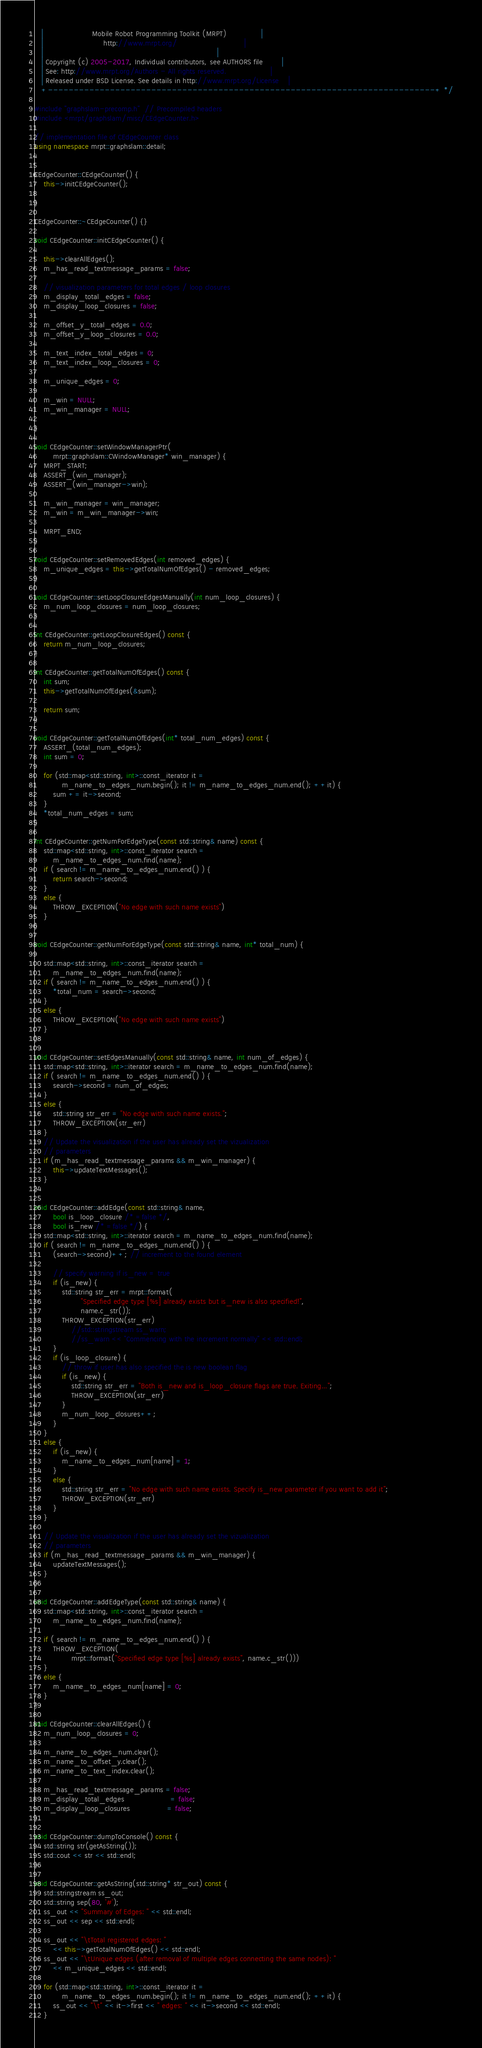Convert code to text. <code><loc_0><loc_0><loc_500><loc_500><_C++_>   |                     Mobile Robot Programming Toolkit (MRPT)               |
   |                          http://www.mrpt.org/                             |
   |                                                                           |
   | Copyright (c) 2005-2017, Individual contributors, see AUTHORS file        |
   | See: http://www.mrpt.org/Authors - All rights reserved.                   |
   | Released under BSD License. See details in http://www.mrpt.org/License    |
   +---------------------------------------------------------------------------+ */

#include "graphslam-precomp.h"  // Precompiled headers
#include <mrpt/graphslam/misc/CEdgeCounter.h>

// implementation file of CEdgeCounter class
using namespace mrpt::graphslam::detail;


CEdgeCounter::CEdgeCounter() {
	this->initCEdgeCounter();

}

CEdgeCounter::~CEdgeCounter() {}

void CEdgeCounter::initCEdgeCounter() {

	this->clearAllEdges();
	m_has_read_textmessage_params = false;

	// visualization parameters for total edges / loop closures
	m_display_total_edges = false;
	m_display_loop_closures = false;

	m_offset_y_total_edges = 0.0;
	m_offset_y_loop_closures = 0.0;

	m_text_index_total_edges = 0;
	m_text_index_loop_closures = 0;

	m_unique_edges = 0;

	m_win = NULL;
	m_win_manager = NULL;

}

void CEdgeCounter::setWindowManagerPtr(
		mrpt::graphslam::CWindowManager* win_manager) {
	MRPT_START;
	ASSERT_(win_manager);
	ASSERT_(win_manager->win);

	m_win_manager = win_manager;
	m_win = m_win_manager->win;

	MRPT_END;
}

void CEdgeCounter::setRemovedEdges(int removed_edges) {
	m_unique_edges = this->getTotalNumOfEdges() - removed_edges;
}

void CEdgeCounter::setLoopClosureEdgesManually(int num_loop_closures) {
	m_num_loop_closures = num_loop_closures;
}

int CEdgeCounter::getLoopClosureEdges() const {
	return m_num_loop_closures;
}

int CEdgeCounter::getTotalNumOfEdges() const {
	int sum;
	this->getTotalNumOfEdges(&sum);

	return sum;
}

void CEdgeCounter::getTotalNumOfEdges(int* total_num_edges) const {
	ASSERT_(total_num_edges);
	int sum = 0;

	for (std::map<std::string, int>::const_iterator it =
			m_name_to_edges_num.begin(); it != m_name_to_edges_num.end(); ++it) {
		sum += it->second;
	}
	*total_num_edges = sum;
}

int CEdgeCounter::getNumForEdgeType(const std::string& name) const {
	std::map<std::string, int>::const_iterator search =
		m_name_to_edges_num.find(name);
	if ( search != m_name_to_edges_num.end() ) {
		return search->second;
	}
	else {
		THROW_EXCEPTION("No edge with such name exists")
	}
}

void CEdgeCounter::getNumForEdgeType(const std::string& name, int* total_num) {

	std::map<std::string, int>::const_iterator search =
		m_name_to_edges_num.find(name);
	if ( search != m_name_to_edges_num.end() ) {
		*total_num = search->second;
	}
	else {
		THROW_EXCEPTION("No edge with such name exists")
	}
}

void CEdgeCounter::setEdgesManually(const std::string& name, int num_of_edges) {
	std::map<std::string, int>::iterator search = m_name_to_edges_num.find(name);
	if ( search != m_name_to_edges_num.end() ) {
		search->second = num_of_edges;
	}
	else {
		std::string str_err = "No edge with such name exists.";
		THROW_EXCEPTION(str_err)
	}
	// Update the visualization if the user has already set the vizualization
	// parameters
	if (m_has_read_textmessage_params && m_win_manager) {
		this->updateTextMessages();
	}
}

void CEdgeCounter::addEdge(const std::string& name,
		bool is_loop_closure /* =false */,
		bool is_new /* =false */) {
	std::map<std::string, int>::iterator search = m_name_to_edges_num.find(name);
	if ( search != m_name_to_edges_num.end() ) {
		(search->second)++; // increment to the found element

		// specify warning if is_new = true
		if (is_new) {
			std::string str_err = mrpt::format(
					"Specified edge type [%s] already exists but is_new is also specified!",
					name.c_str());
			THROW_EXCEPTION(str_err)
				//std::stringstream ss_warn;
				//ss_warn << "Commencing with the increment normally" << std::endl;
		}
		if (is_loop_closure) {
			// throw if user has also specified the is new boolean flag
			if (is_new) {
				std::string str_err = "Both is_new and is_loop_closure flags are true. Exiting...";
				THROW_EXCEPTION(str_err)
			}
			m_num_loop_closures++;
		}
	}
	else {
		if (is_new) {
			m_name_to_edges_num[name] = 1;
		}
		else {
			std::string str_err = "No edge with such name exists. Specify is_new parameter if you want to add it";
			THROW_EXCEPTION(str_err)
		}
	}

	// Update the visualization if the user has already set the vizualization
	// parameters
	if (m_has_read_textmessage_params && m_win_manager) {
		updateTextMessages();
	}
}

void CEdgeCounter::addEdgeType(const std::string& name) {
	std::map<std::string, int>::const_iterator search =
		m_name_to_edges_num.find(name);

	if ( search != m_name_to_edges_num.end() ) {
		THROW_EXCEPTION(
				mrpt::format("Specified edge type [%s] already exists", name.c_str()))
	}
	else {
		m_name_to_edges_num[name] = 0;
	}
}

void CEdgeCounter::clearAllEdges() {
	m_num_loop_closures = 0;

	m_name_to_edges_num.clear();
	m_name_to_offset_y.clear();
	m_name_to_text_index.clear();

	m_has_read_textmessage_params = false;
	m_display_total_edges					= false;
	m_display_loop_closures				= false;
}

void CEdgeCounter::dumpToConsole() const {
	std::string str(getAsString());
	std::cout << str << std::endl;
}

void CEdgeCounter::getAsString(std::string* str_out) const {
	std::stringstream ss_out;
	std::string sep(80, '#');
	ss_out << "Summary of Edges: " << std::endl;
	ss_out << sep << std::endl;

	ss_out << "\tTotal registered edges: "
		<< this->getTotalNumOfEdges() << std::endl;
	ss_out << "\tUnique edges (after removal of multiple edges connecting the same nodes): "
		<< m_unique_edges << std::endl;

	for (std::map<std::string, int>::const_iterator it =
			m_name_to_edges_num.begin(); it != m_name_to_edges_num.end(); ++it) {
		ss_out << "\t" << it->first << " edges: " << it->second << std::endl;
	}</code> 